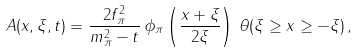Convert formula to latex. <formula><loc_0><loc_0><loc_500><loc_500>A ( x , \xi , t ) = \frac { 2 f ^ { 2 } _ { \pi } } { m ^ { 2 } _ { \pi } - t } \, \phi _ { \pi } \left ( \frac { x + \xi } { 2 \xi } \right ) \, \theta ( \xi \geq x \geq - \xi ) \, ,</formula> 